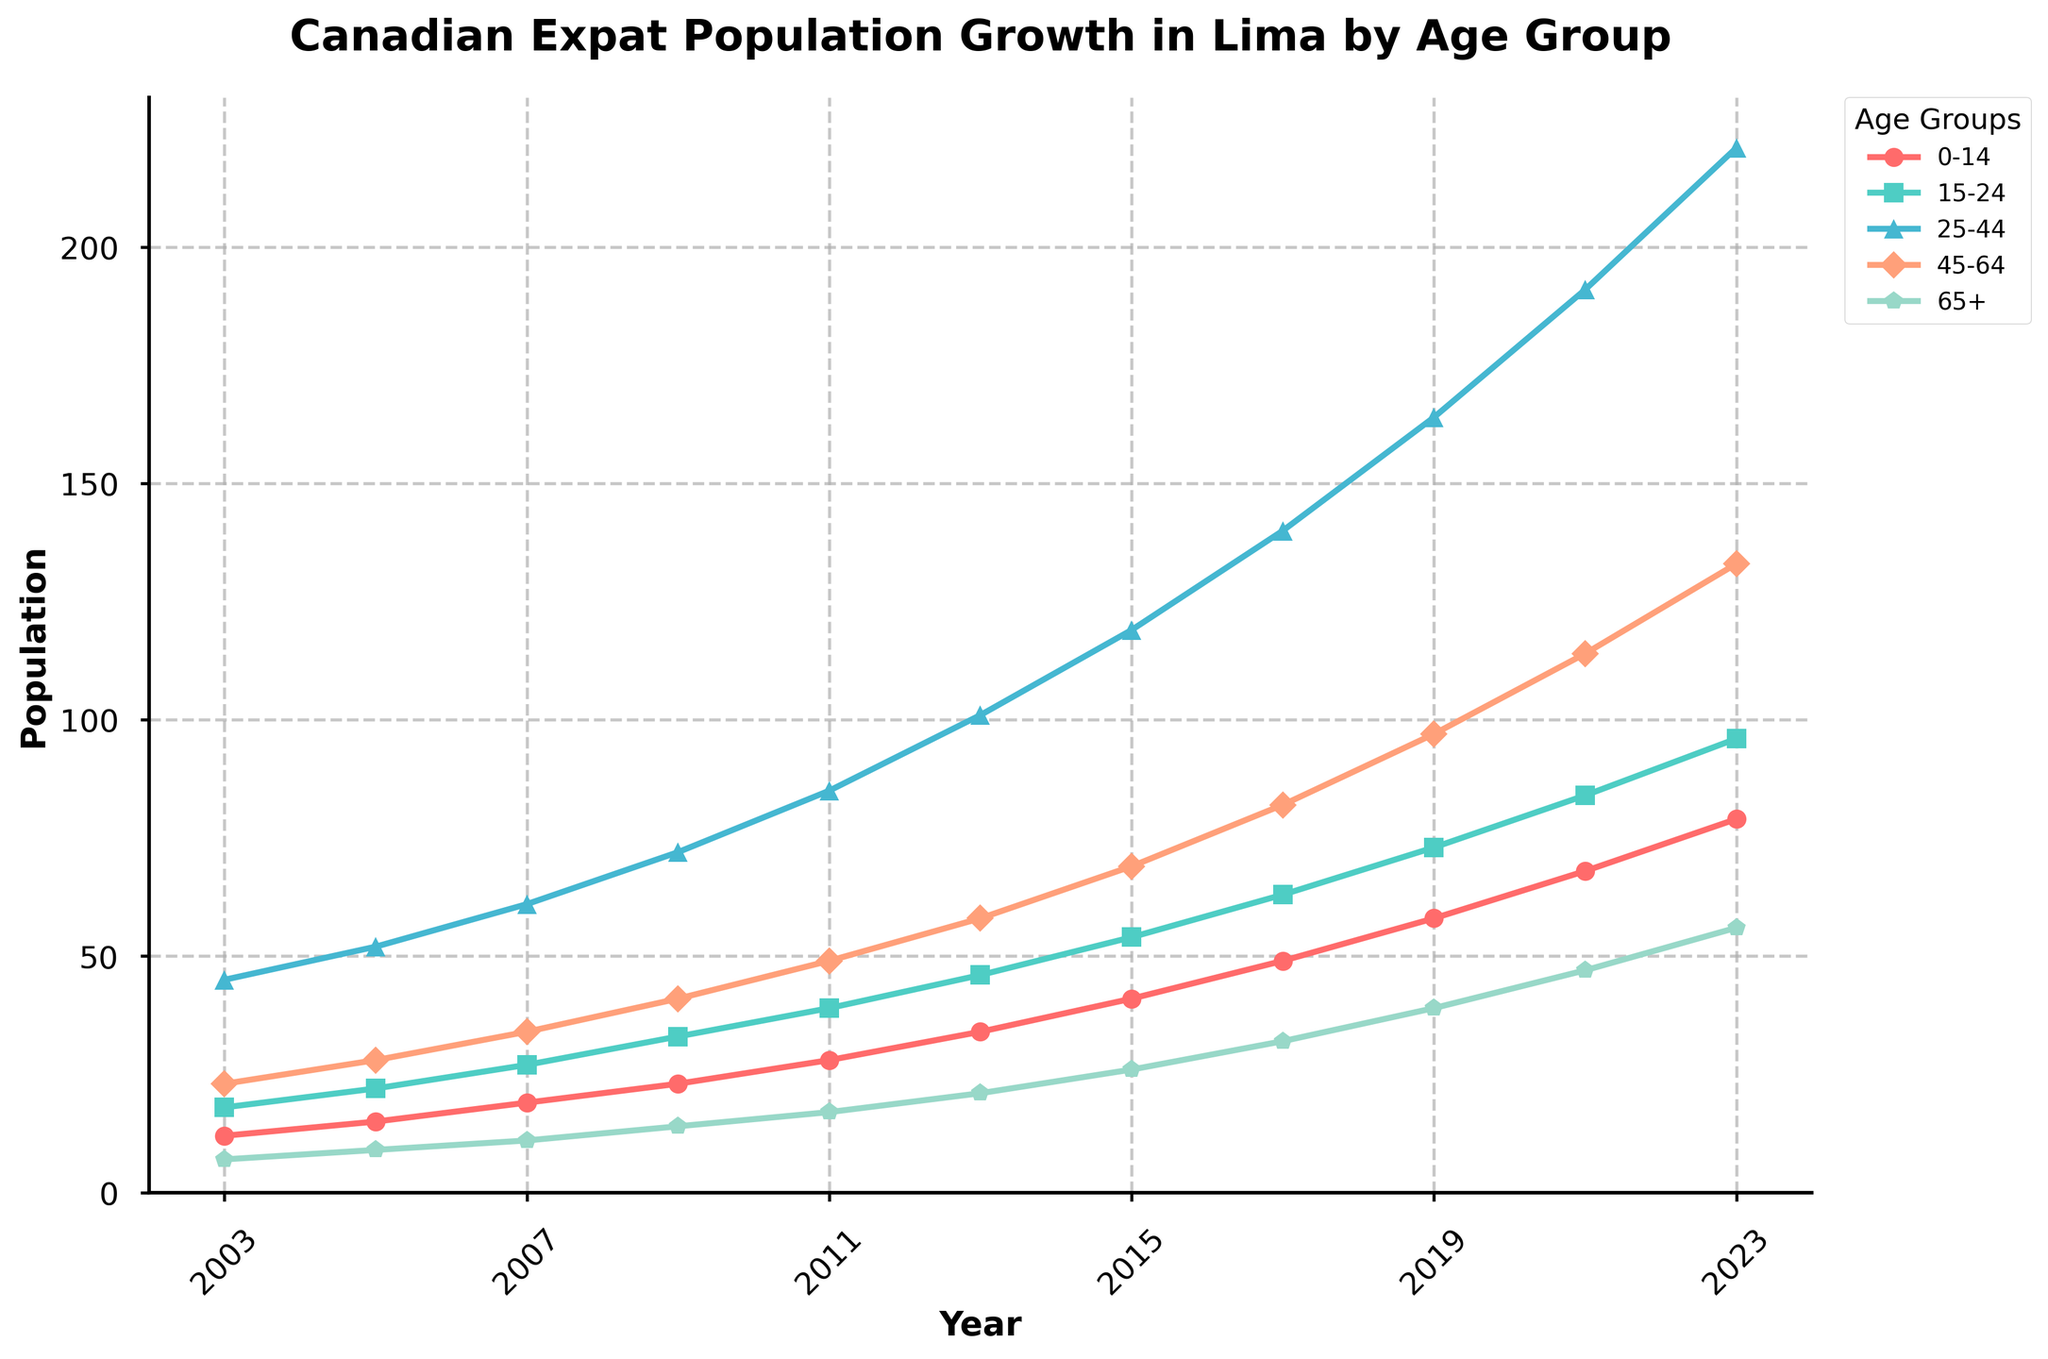What's the population growth of the 25-44 age group from 2003 to 2023? To find the population growth of the 25-44 age group, we need to subtract the population in 2003 from the population in 2023. The data shows 221 in 2023 and 45 in 2003. Thus, the growth is 221 - 45 = 176.
Answer: 176 Which age group has the highest population in 2023? By looking at the chart, the age group with the highest population in 2023 is the 25-44 age group, which has 221 individuals.
Answer: 25-44 How does the population of the 65+ age group in 2009 compare to the 0-14 age group in the same year? In 2009, we need to compare the populations of the two age groups. The 65+ age group has 14 individuals while the 0-14 age group has 23. Therefore, the 0-14 age group is larger.
Answer: The 0-14 age group is larger What is the average population of the 45-64 age group over the entire period? To find the average population, add up the values from each year for the 45-64 age group and then divide by the number of years. ((23 + 28 + 34 + 41 + 49 + 58 + 69 + 82 + 97 + 114 + 133)/11) = 58.55.
Answer: 58.55 In which year did the 15-24 age group first surpass 60 individuals? By looking at the chart, the 15-24 age group first surpassed 60 individuals in 2017, as the population became 63.
Answer: 2017 Which age groups have shown a consistent increase every year? By reviewing the chart, the 25-44, 45-64, and 65+ age groups have shown a consistent increase every year without any declines.
Answer: 25-44, 45-64, 65+ By how much has the population of the 0-14 age group increased from 2003 to 2013? To find this, we subtract the population in 2003 from 2013 for the 0-14 age group: 34 - 12 = 22.
Answer: 22 What is the difference in the population of the 15-24 age group between 2015 and 2019? Subtract the population in 2015 from the population in 2019 for the 15-24 age group: 73 - 54 = 19.
Answer: 19 If the trend continues, what might you expect the population of the 45-64 age group to be in 2025? Observing the trend, the 45-64 age group increases by approximately 19 individuals every two years. From 2023 (133), adding 19 gives an expected 152 in 2025.
Answer: 152 